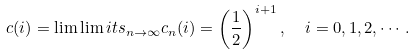Convert formula to latex. <formula><loc_0><loc_0><loc_500><loc_500>c ( i ) = \lim \lim i t s _ { n \to \infty } c _ { n } ( i ) = \left ( \frac { 1 } { 2 } \right ) ^ { i + 1 } , \ \ i = 0 , 1 , 2 , \cdots .</formula> 